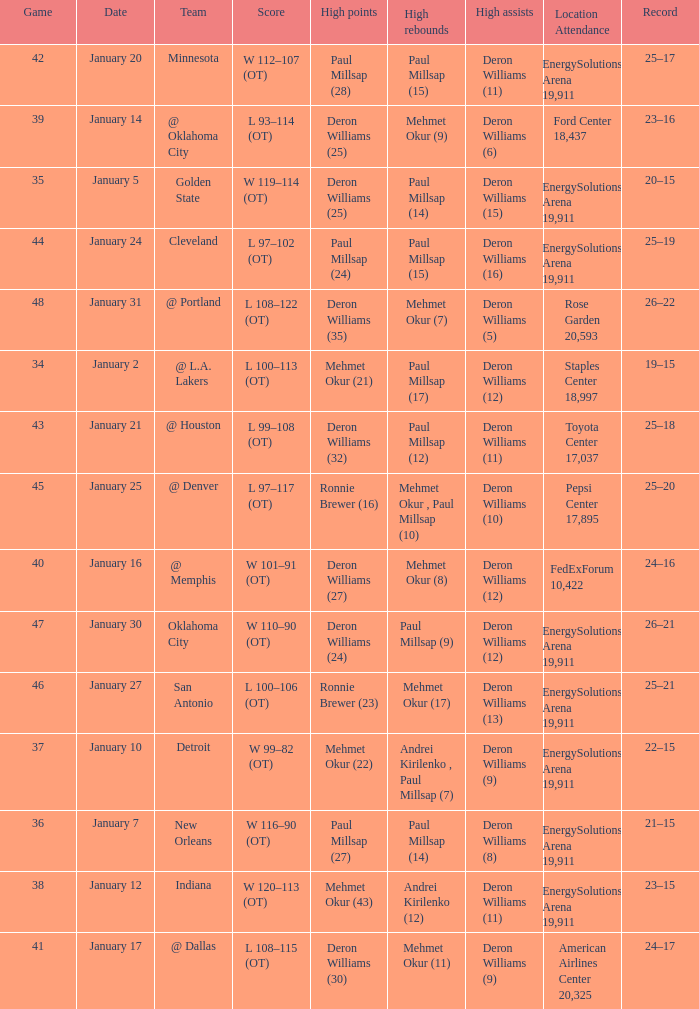What was the score of Game 48? L 108–122 (OT). 